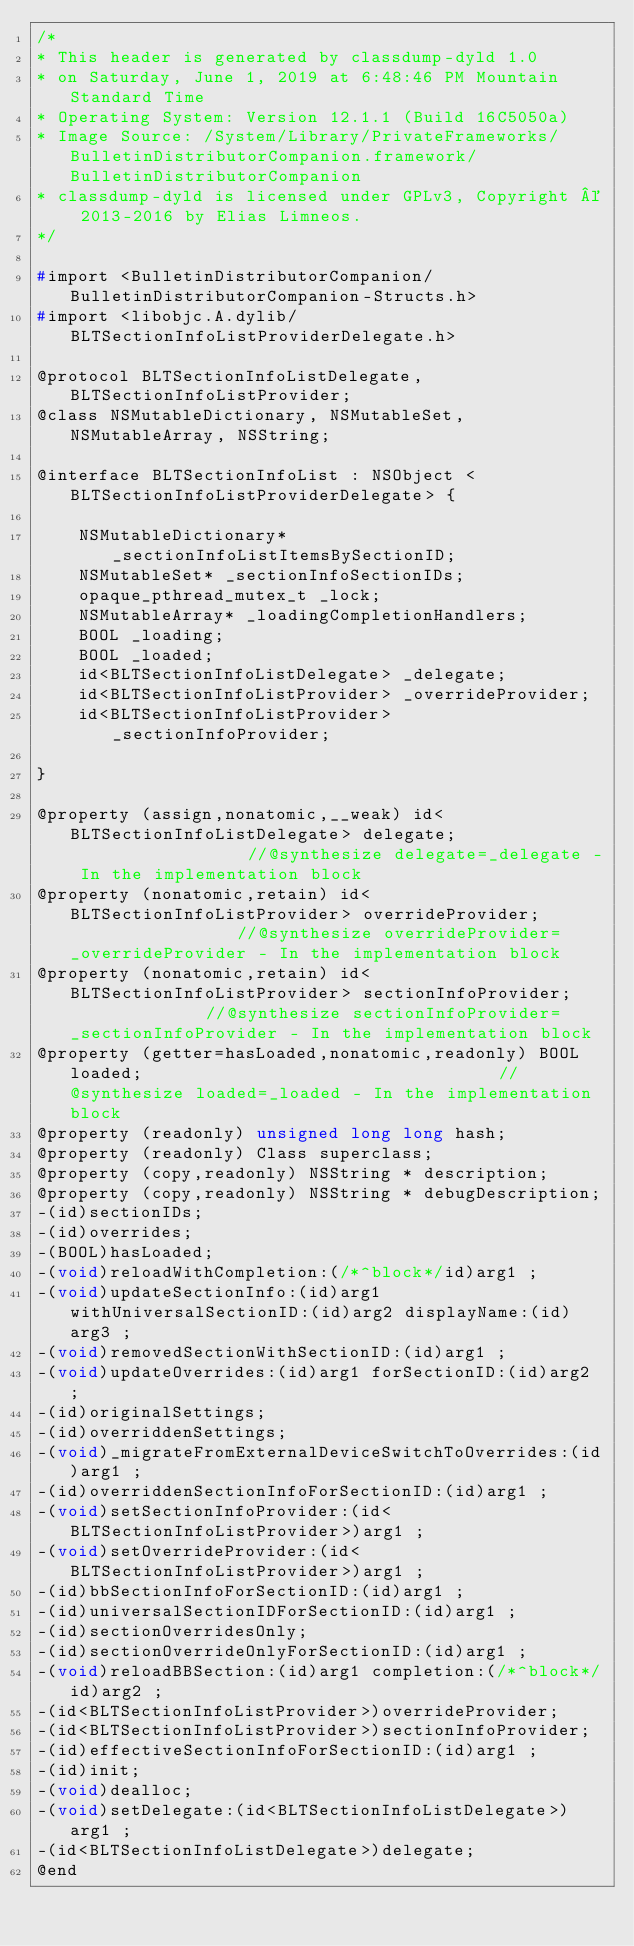Convert code to text. <code><loc_0><loc_0><loc_500><loc_500><_C_>/*
* This header is generated by classdump-dyld 1.0
* on Saturday, June 1, 2019 at 6:48:46 PM Mountain Standard Time
* Operating System: Version 12.1.1 (Build 16C5050a)
* Image Source: /System/Library/PrivateFrameworks/BulletinDistributorCompanion.framework/BulletinDistributorCompanion
* classdump-dyld is licensed under GPLv3, Copyright © 2013-2016 by Elias Limneos.
*/

#import <BulletinDistributorCompanion/BulletinDistributorCompanion-Structs.h>
#import <libobjc.A.dylib/BLTSectionInfoListProviderDelegate.h>

@protocol BLTSectionInfoListDelegate, BLTSectionInfoListProvider;
@class NSMutableDictionary, NSMutableSet, NSMutableArray, NSString;

@interface BLTSectionInfoList : NSObject <BLTSectionInfoListProviderDelegate> {

	NSMutableDictionary* _sectionInfoListItemsBySectionID;
	NSMutableSet* _sectionInfoSectionIDs;
	opaque_pthread_mutex_t _lock;
	NSMutableArray* _loadingCompletionHandlers;
	BOOL _loading;
	BOOL _loaded;
	id<BLTSectionInfoListDelegate> _delegate;
	id<BLTSectionInfoListProvider> _overrideProvider;
	id<BLTSectionInfoListProvider> _sectionInfoProvider;

}

@property (assign,nonatomic,__weak) id<BLTSectionInfoListDelegate> delegate;                  //@synthesize delegate=_delegate - In the implementation block
@property (nonatomic,retain) id<BLTSectionInfoListProvider> overrideProvider;                 //@synthesize overrideProvider=_overrideProvider - In the implementation block
@property (nonatomic,retain) id<BLTSectionInfoListProvider> sectionInfoProvider;              //@synthesize sectionInfoProvider=_sectionInfoProvider - In the implementation block
@property (getter=hasLoaded,nonatomic,readonly) BOOL loaded;                                  //@synthesize loaded=_loaded - In the implementation block
@property (readonly) unsigned long long hash; 
@property (readonly) Class superclass; 
@property (copy,readonly) NSString * description; 
@property (copy,readonly) NSString * debugDescription; 
-(id)sectionIDs;
-(id)overrides;
-(BOOL)hasLoaded;
-(void)reloadWithCompletion:(/*^block*/id)arg1 ;
-(void)updateSectionInfo:(id)arg1 withUniversalSectionID:(id)arg2 displayName:(id)arg3 ;
-(void)removedSectionWithSectionID:(id)arg1 ;
-(void)updateOverrides:(id)arg1 forSectionID:(id)arg2 ;
-(id)originalSettings;
-(id)overriddenSettings;
-(void)_migrateFromExternalDeviceSwitchToOverrides:(id)arg1 ;
-(id)overriddenSectionInfoForSectionID:(id)arg1 ;
-(void)setSectionInfoProvider:(id<BLTSectionInfoListProvider>)arg1 ;
-(void)setOverrideProvider:(id<BLTSectionInfoListProvider>)arg1 ;
-(id)bbSectionInfoForSectionID:(id)arg1 ;
-(id)universalSectionIDForSectionID:(id)arg1 ;
-(id)sectionOverridesOnly;
-(id)sectionOverrideOnlyForSectionID:(id)arg1 ;
-(void)reloadBBSection:(id)arg1 completion:(/*^block*/id)arg2 ;
-(id<BLTSectionInfoListProvider>)overrideProvider;
-(id<BLTSectionInfoListProvider>)sectionInfoProvider;
-(id)effectiveSectionInfoForSectionID:(id)arg1 ;
-(id)init;
-(void)dealloc;
-(void)setDelegate:(id<BLTSectionInfoListDelegate>)arg1 ;
-(id<BLTSectionInfoListDelegate>)delegate;
@end

</code> 